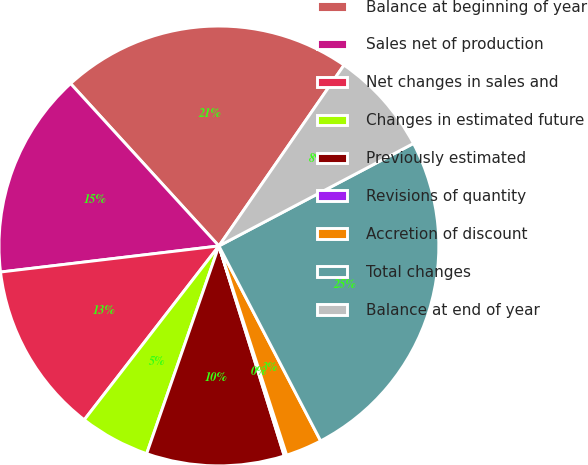<chart> <loc_0><loc_0><loc_500><loc_500><pie_chart><fcel>Balance at beginning of year<fcel>Sales net of production<fcel>Net changes in sales and<fcel>Changes in estimated future<fcel>Previously estimated<fcel>Revisions of quantity<fcel>Accretion of discount<fcel>Total changes<fcel>Balance at end of year<nl><fcel>21.41%<fcel>15.11%<fcel>12.62%<fcel>5.16%<fcel>10.13%<fcel>0.18%<fcel>2.67%<fcel>25.06%<fcel>7.65%<nl></chart> 